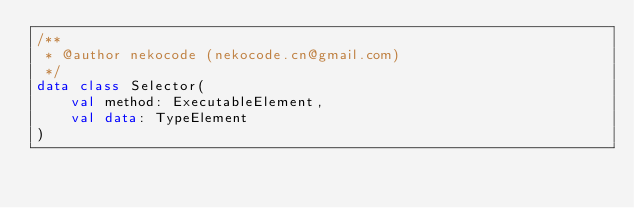Convert code to text. <code><loc_0><loc_0><loc_500><loc_500><_Kotlin_>/**
 * @author nekocode (nekocode.cn@gmail.com)
 */
data class Selector(
    val method: ExecutableElement,
    val data: TypeElement
)</code> 